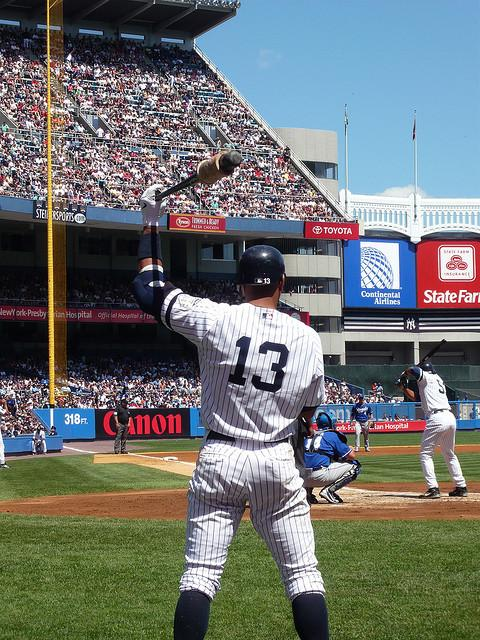What is the thing on the baseball bat for? weight 